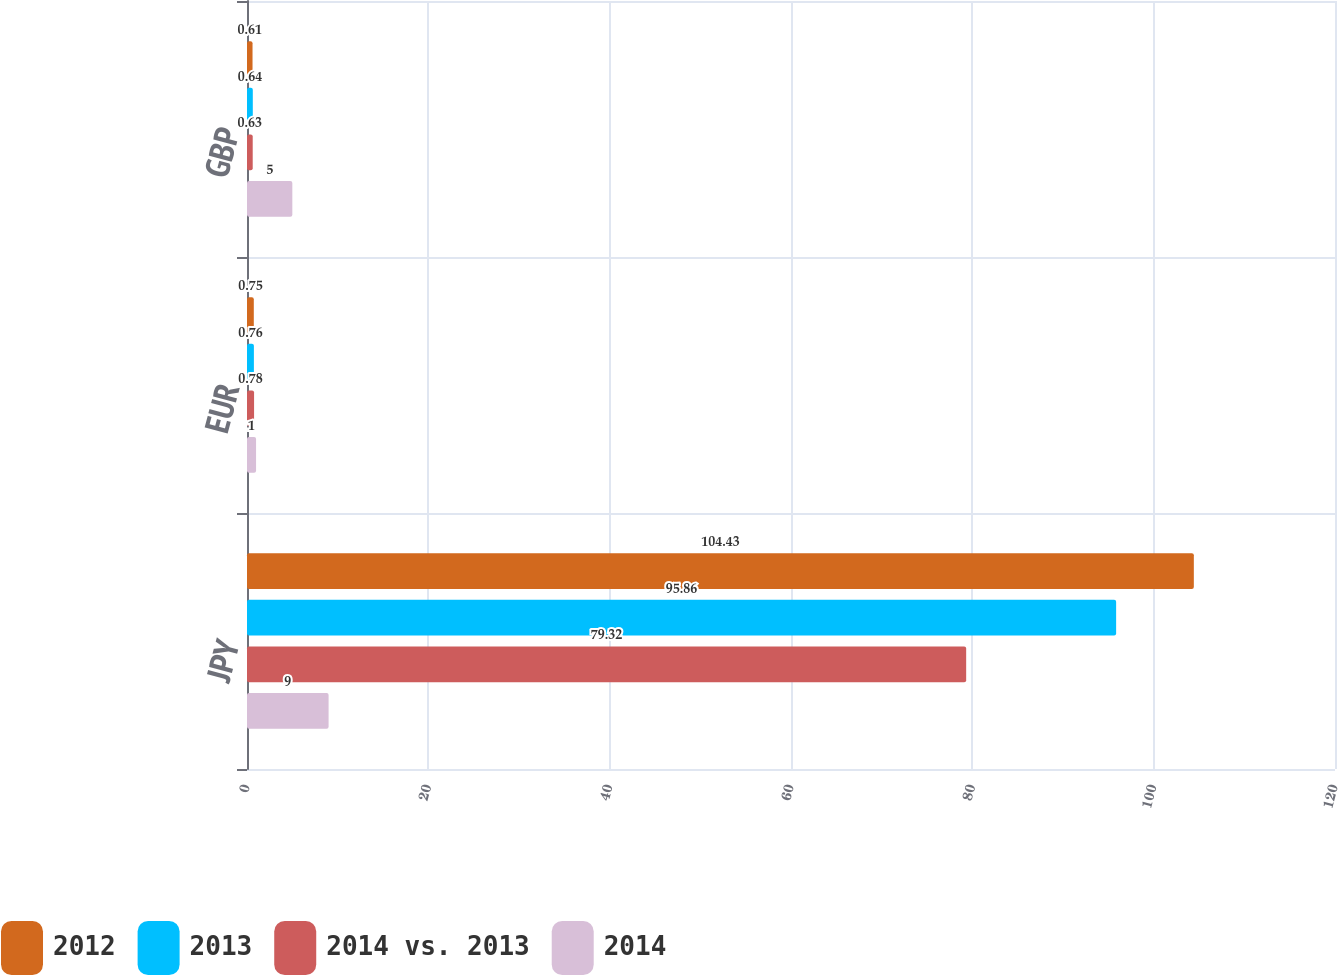<chart> <loc_0><loc_0><loc_500><loc_500><stacked_bar_chart><ecel><fcel>JPY<fcel>EUR<fcel>GBP<nl><fcel>2012<fcel>104.43<fcel>0.75<fcel>0.61<nl><fcel>2013<fcel>95.86<fcel>0.76<fcel>0.64<nl><fcel>2014 vs. 2013<fcel>79.32<fcel>0.78<fcel>0.63<nl><fcel>2014<fcel>9<fcel>1<fcel>5<nl></chart> 